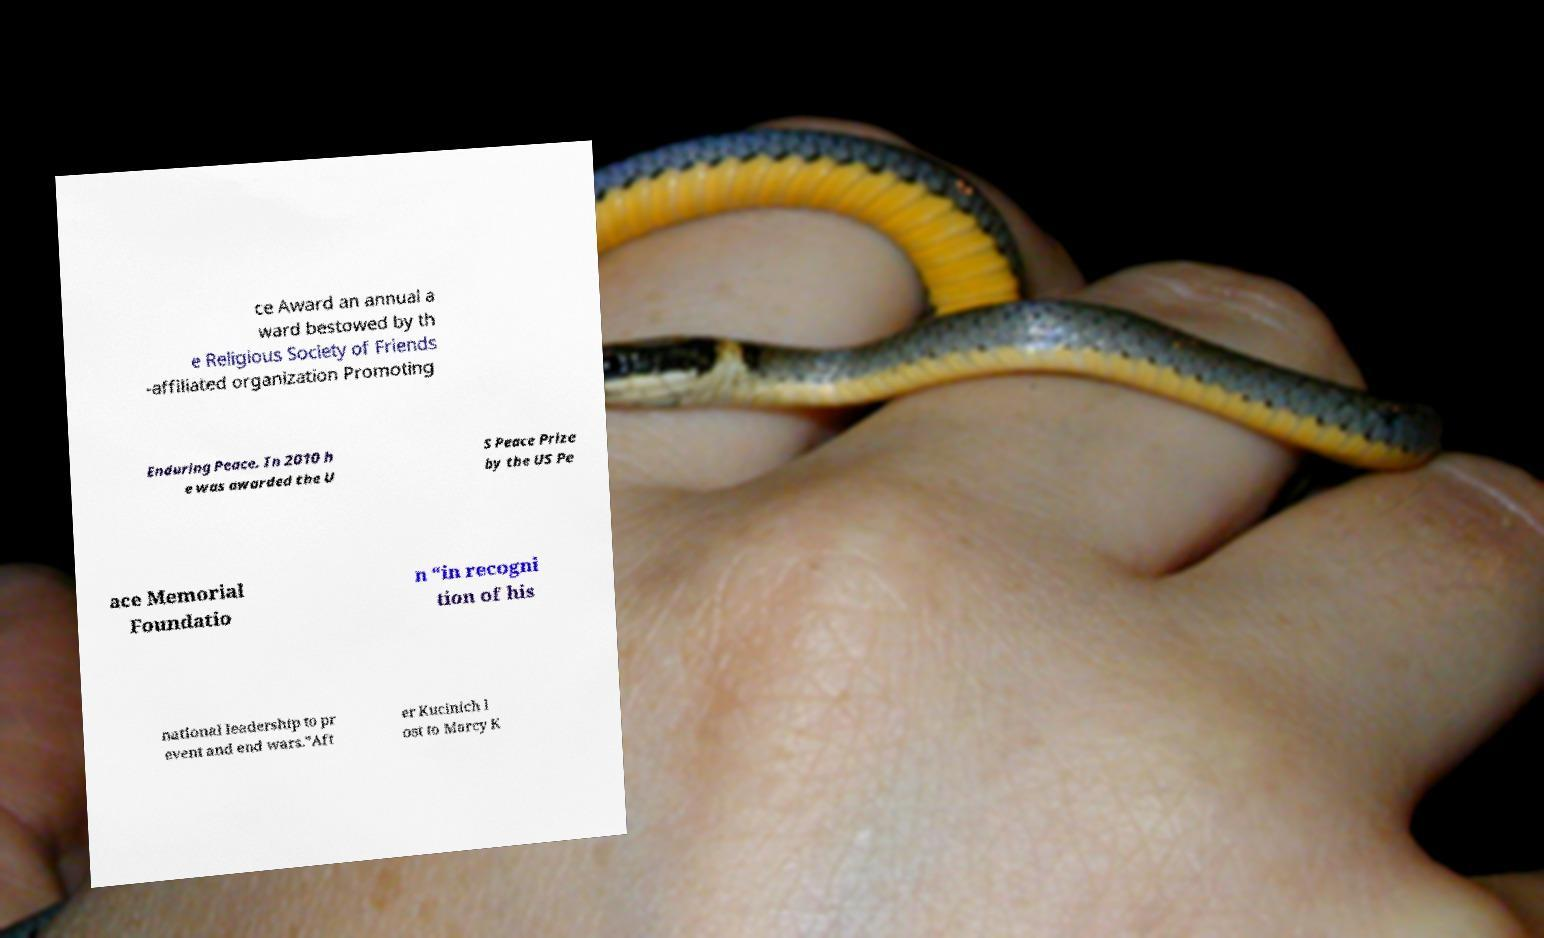Could you extract and type out the text from this image? ce Award an annual a ward bestowed by th e Religious Society of Friends -affiliated organization Promoting Enduring Peace. In 2010 h e was awarded the U S Peace Prize by the US Pe ace Memorial Foundatio n “in recogni tion of his national leadership to pr event and end wars.”Aft er Kucinich l ost to Marcy K 